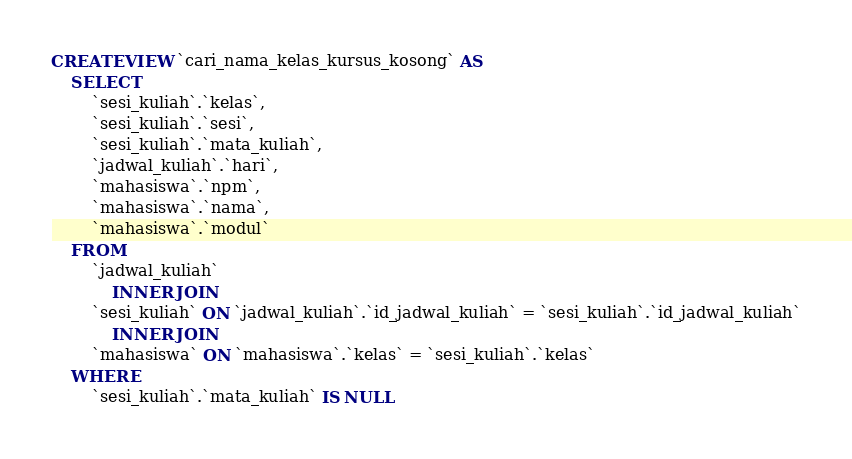<code> <loc_0><loc_0><loc_500><loc_500><_SQL_>CREATE VIEW `cari_nama_kelas_kursus_kosong` AS
    SELECT 
        `sesi_kuliah`.`kelas`,
        `sesi_kuliah`.`sesi`,
        `sesi_kuliah`.`mata_kuliah`,
        `jadwal_kuliah`.`hari`,
        `mahasiswa`.`npm`,
        `mahasiswa`.`nama`,
        `mahasiswa`.`modul`
    FROM
        `jadwal_kuliah`
            INNER JOIN
        `sesi_kuliah` ON `jadwal_kuliah`.`id_jadwal_kuliah` = `sesi_kuliah`.`id_jadwal_kuliah`
            INNER JOIN
        `mahasiswa` ON `mahasiswa`.`kelas` = `sesi_kuliah`.`kelas`
    WHERE
        `sesi_kuliah`.`mata_kuliah` IS NULL</code> 